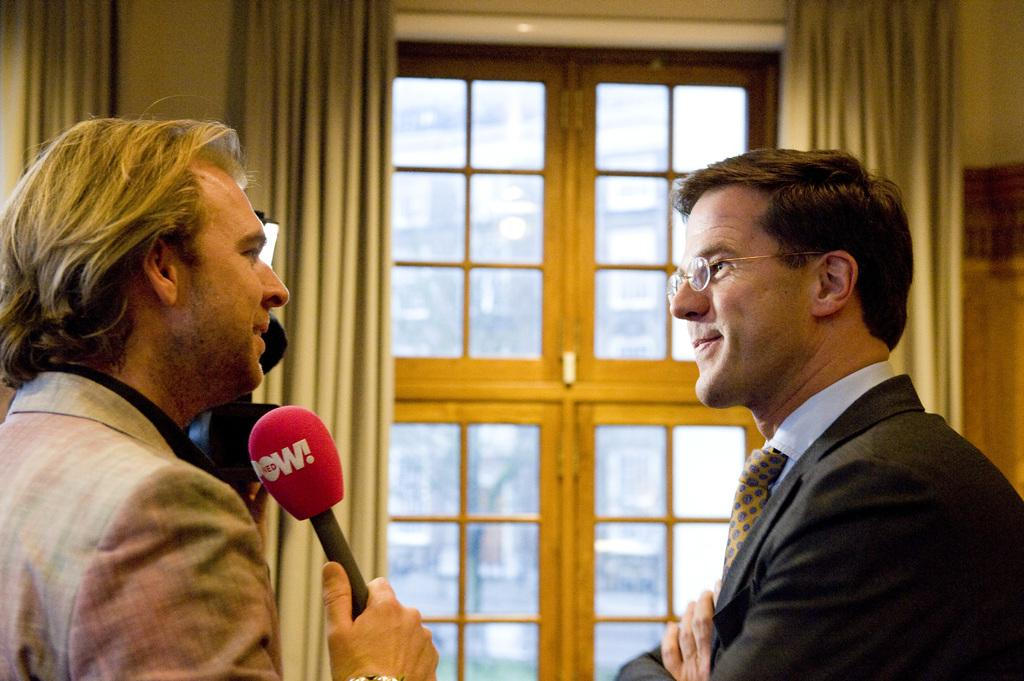How many people are present in the image? There are two persons in the image. What is one person doing with the microphone? One person is catching the microphone. What is the other person doing in response to the first person? The other person is listening to the first person. What type of window treatment is present in the image? There is a curtain near a window in the image. What is the title of the book the person is holding in the image? There is no book present in the image, so there is no title to reference. 